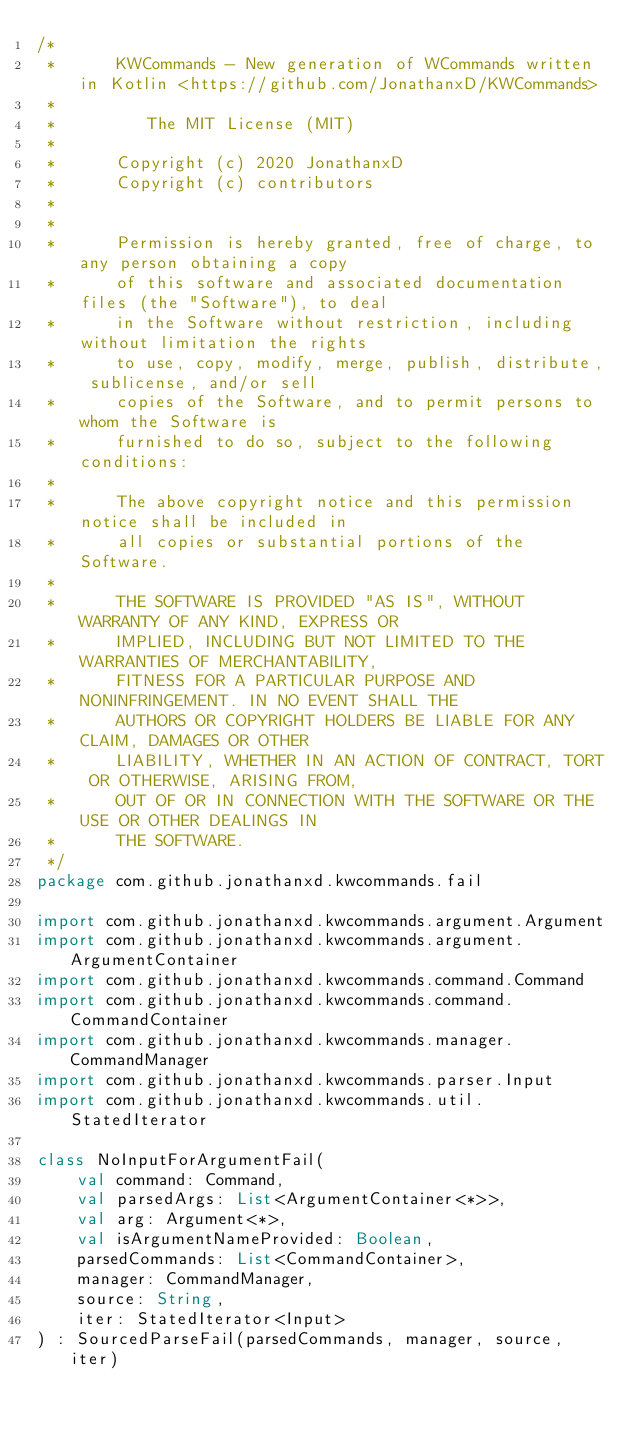Convert code to text. <code><loc_0><loc_0><loc_500><loc_500><_Kotlin_>/*
 *      KWCommands - New generation of WCommands written in Kotlin <https://github.com/JonathanxD/KWCommands>
 *
 *         The MIT License (MIT)
 *
 *      Copyright (c) 2020 JonathanxD
 *      Copyright (c) contributors
 *
 *
 *      Permission is hereby granted, free of charge, to any person obtaining a copy
 *      of this software and associated documentation files (the "Software"), to deal
 *      in the Software without restriction, including without limitation the rights
 *      to use, copy, modify, merge, publish, distribute, sublicense, and/or sell
 *      copies of the Software, and to permit persons to whom the Software is
 *      furnished to do so, subject to the following conditions:
 *
 *      The above copyright notice and this permission notice shall be included in
 *      all copies or substantial portions of the Software.
 *
 *      THE SOFTWARE IS PROVIDED "AS IS", WITHOUT WARRANTY OF ANY KIND, EXPRESS OR
 *      IMPLIED, INCLUDING BUT NOT LIMITED TO THE WARRANTIES OF MERCHANTABILITY,
 *      FITNESS FOR A PARTICULAR PURPOSE AND NONINFRINGEMENT. IN NO EVENT SHALL THE
 *      AUTHORS OR COPYRIGHT HOLDERS BE LIABLE FOR ANY CLAIM, DAMAGES OR OTHER
 *      LIABILITY, WHETHER IN AN ACTION OF CONTRACT, TORT OR OTHERWISE, ARISING FROM,
 *      OUT OF OR IN CONNECTION WITH THE SOFTWARE OR THE USE OR OTHER DEALINGS IN
 *      THE SOFTWARE.
 */
package com.github.jonathanxd.kwcommands.fail

import com.github.jonathanxd.kwcommands.argument.Argument
import com.github.jonathanxd.kwcommands.argument.ArgumentContainer
import com.github.jonathanxd.kwcommands.command.Command
import com.github.jonathanxd.kwcommands.command.CommandContainer
import com.github.jonathanxd.kwcommands.manager.CommandManager
import com.github.jonathanxd.kwcommands.parser.Input
import com.github.jonathanxd.kwcommands.util.StatedIterator

class NoInputForArgumentFail(
    val command: Command,
    val parsedArgs: List<ArgumentContainer<*>>,
    val arg: Argument<*>,
    val isArgumentNameProvided: Boolean,
    parsedCommands: List<CommandContainer>,
    manager: CommandManager,
    source: String,
    iter: StatedIterator<Input>
) : SourcedParseFail(parsedCommands, manager, source, iter)</code> 